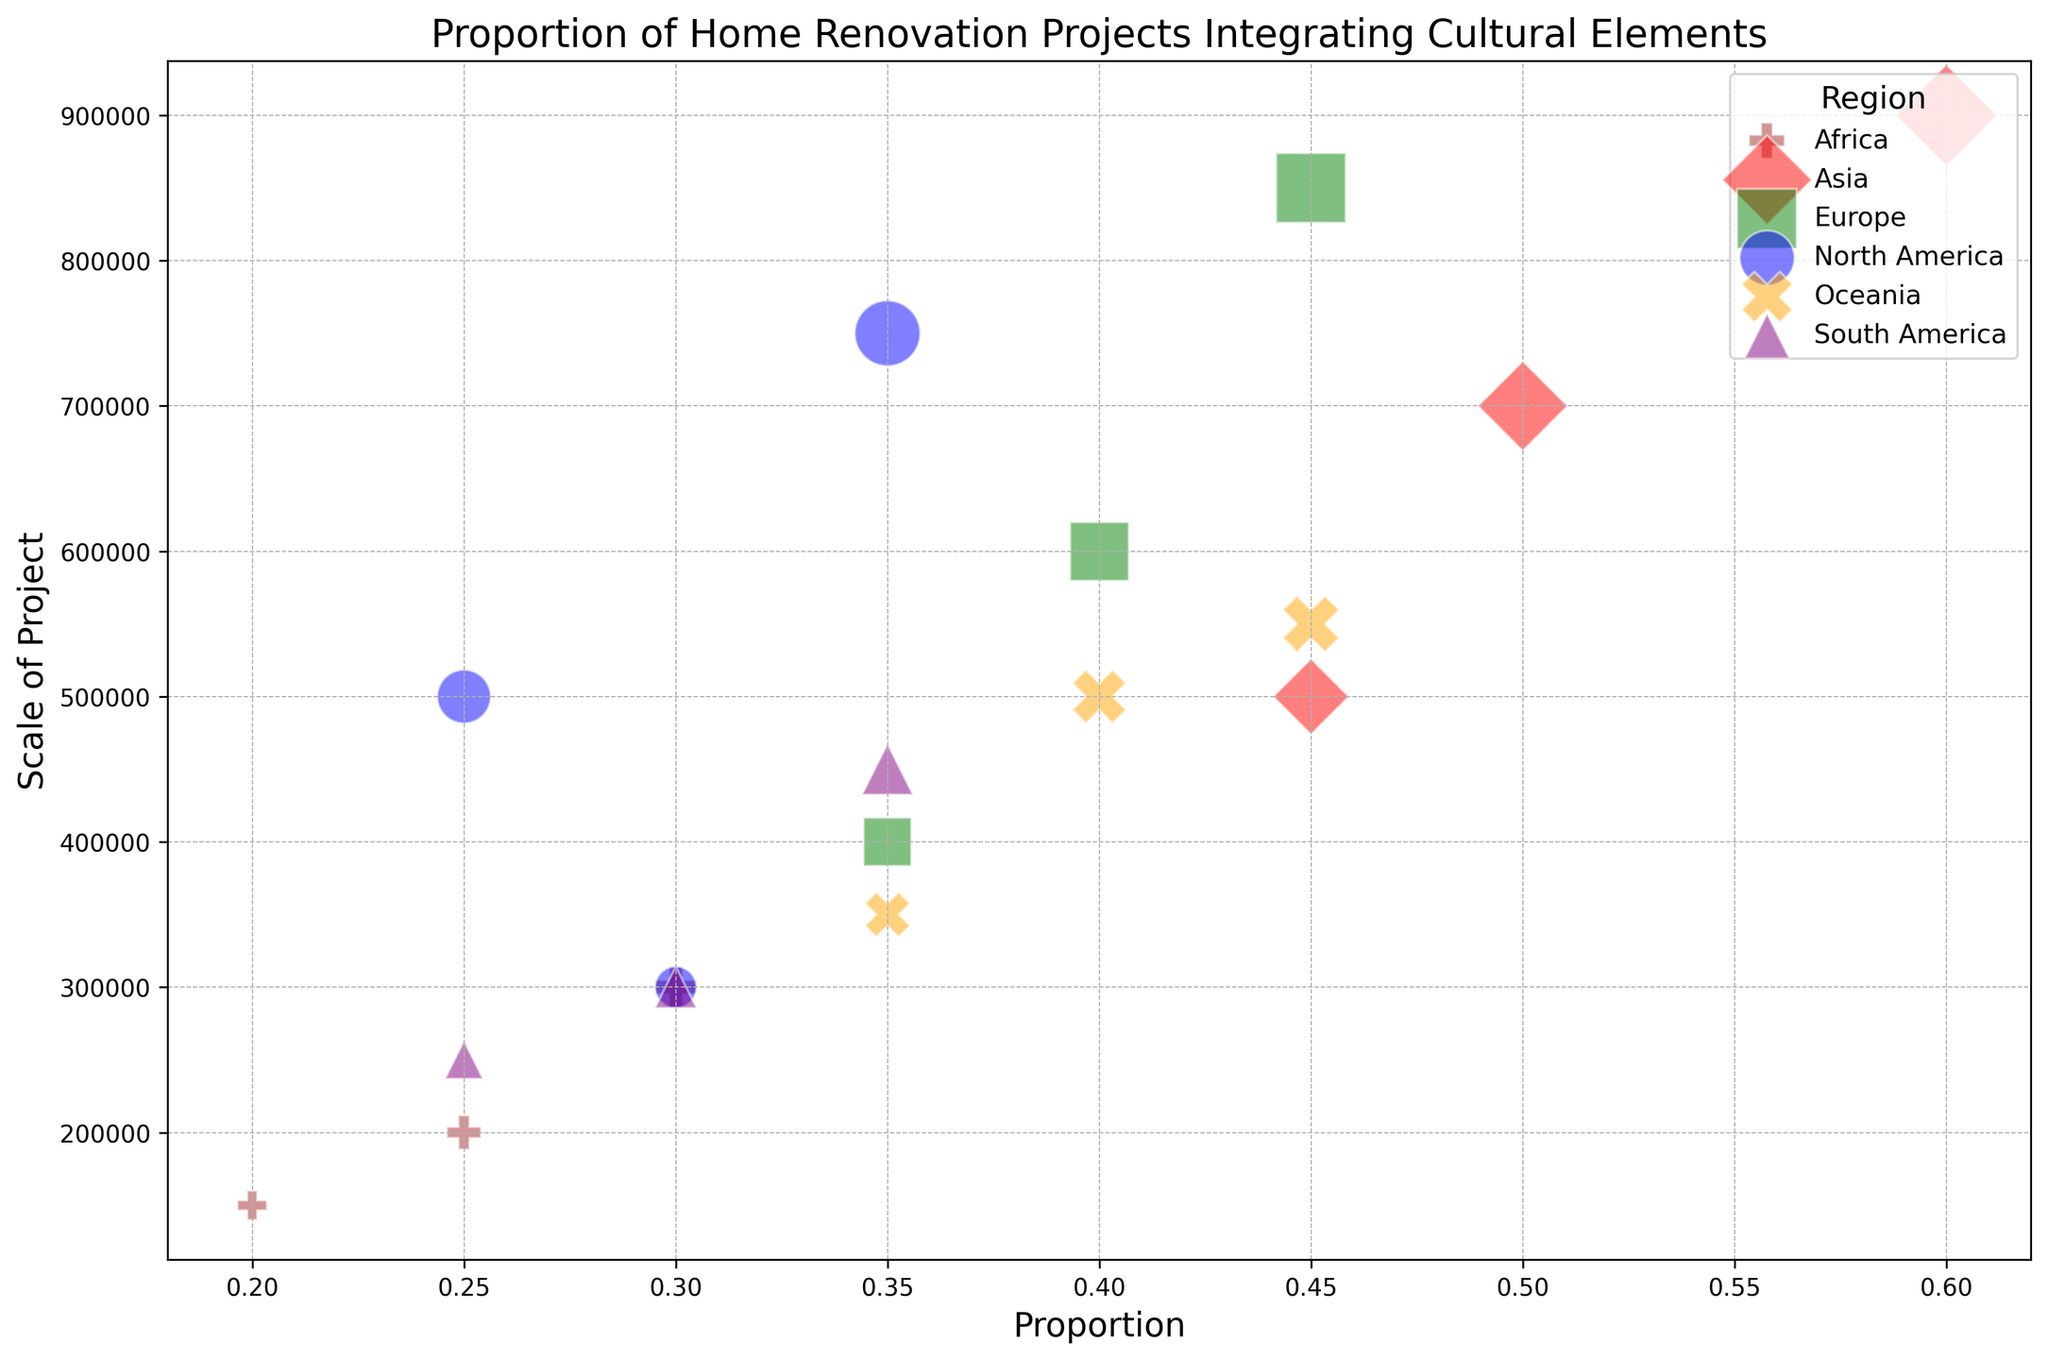What region has the highest proportion of home renovation projects that integrate cultural design elements? The bubble corresponding to Asia has the highest proportion, with one of its bubbles reaching 0.60 on the x-axis.
Answer: Asia Which two regions have the smallest scale of renovation projects that integrate cultural design elements and what are their scales? The smallest scales are found in Africa (150,000) and South America (250,000) as indicated by the relative size of the bubbles.
Answer: Africa and South America; 150,000 and 250,000 respectively Compare the scale of projects between North America and Europe. In which region do projects tend to be larger? By observing the bubble sizes, the bubbles associated with Europe are generally larger than those of North America.
Answer: Europe What is the proportion range for South America’s renovation projects that integrate cultural design elements? The South American bubbles are located between 0.25 and 0.35 on the x-axis.
Answer: 0.25 to 0.35 Which region has the most variability in the proportion of home renovation projects that integrate cultural design elements? Asia has the most variability, with proportions ranging from 0.45 to 0.60, indicating a wide spread on the x-axis.
Answer: Asia What is the average proportion of home renovation projects that integrate cultural design elements for Oceania? The proportions for Oceania are 0.35, 0.40, and 0.45. Summing them gives 1.20, and dividing by 3 gives an average proportion of 0.40.
Answer: 0.40 Which region has the lowest average proportion of integrating cultural design elements in their home renovation projects? Africa has proportions of 0.20, 0.25, and 0.30. Summing them gives 0.75, and dividing by 3 gives an average of 0.25. No other region has a lower average proportion.
Answer: Africa Observe the bubbles for North America and Europe. Which region has the highest proportion for a single project and what is that proportion? The highest single proportion for Europe is 0.45, which is greater than the highest single proportion for North America which is 0.35.
Answer: Europe; 0.45 